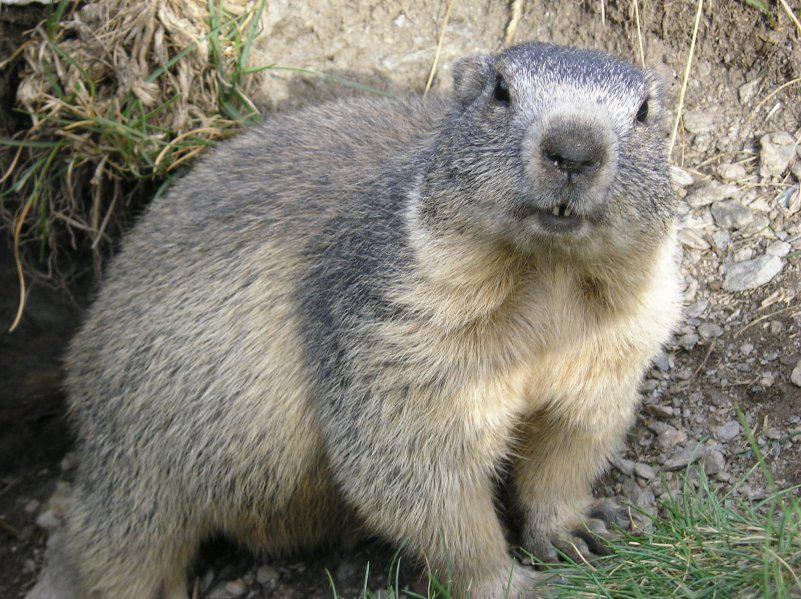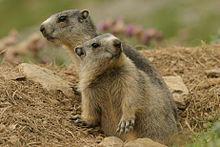The first image is the image on the left, the second image is the image on the right. Evaluate the accuracy of this statement regarding the images: "In one image there is a lone marmot looking towards the camera.". Is it true? Answer yes or no. Yes. The first image is the image on the left, the second image is the image on the right. Considering the images on both sides, is "A boy is kneeling on the ground as he plays with at least 3 groundhogs." valid? Answer yes or no. No. 